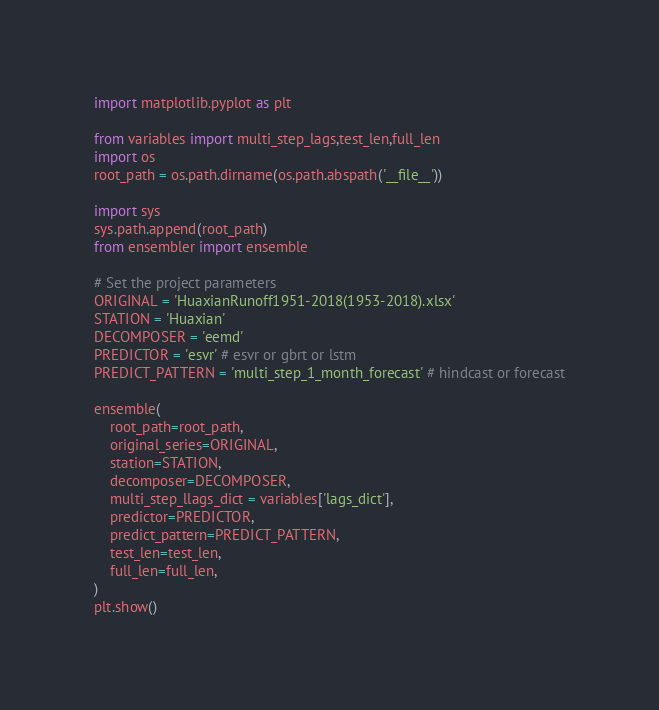<code> <loc_0><loc_0><loc_500><loc_500><_Python_>import matplotlib.pyplot as plt

from variables import multi_step_lags,test_len,full_len
import os
root_path = os.path.dirname(os.path.abspath('__file__')) 

import sys
sys.path.append(root_path)
from ensembler import ensemble

# Set the project parameters
ORIGINAL = 'HuaxianRunoff1951-2018(1953-2018).xlsx'
STATION = 'Huaxian'
DECOMPOSER = 'eemd' 
PREDICTOR = 'esvr' # esvr or gbrt or lstm
PREDICT_PATTERN = 'multi_step_1_month_forecast' # hindcast or forecast

ensemble(
    root_path=root_path,
    original_series=ORIGINAL,
    station=STATION,
    decomposer=DECOMPOSER,
    multi_step_llags_dict = variables['lags_dict'],
    predictor=PREDICTOR,
    predict_pattern=PREDICT_PATTERN,
    test_len=test_len,
    full_len=full_len,
)
plt.show()
</code> 